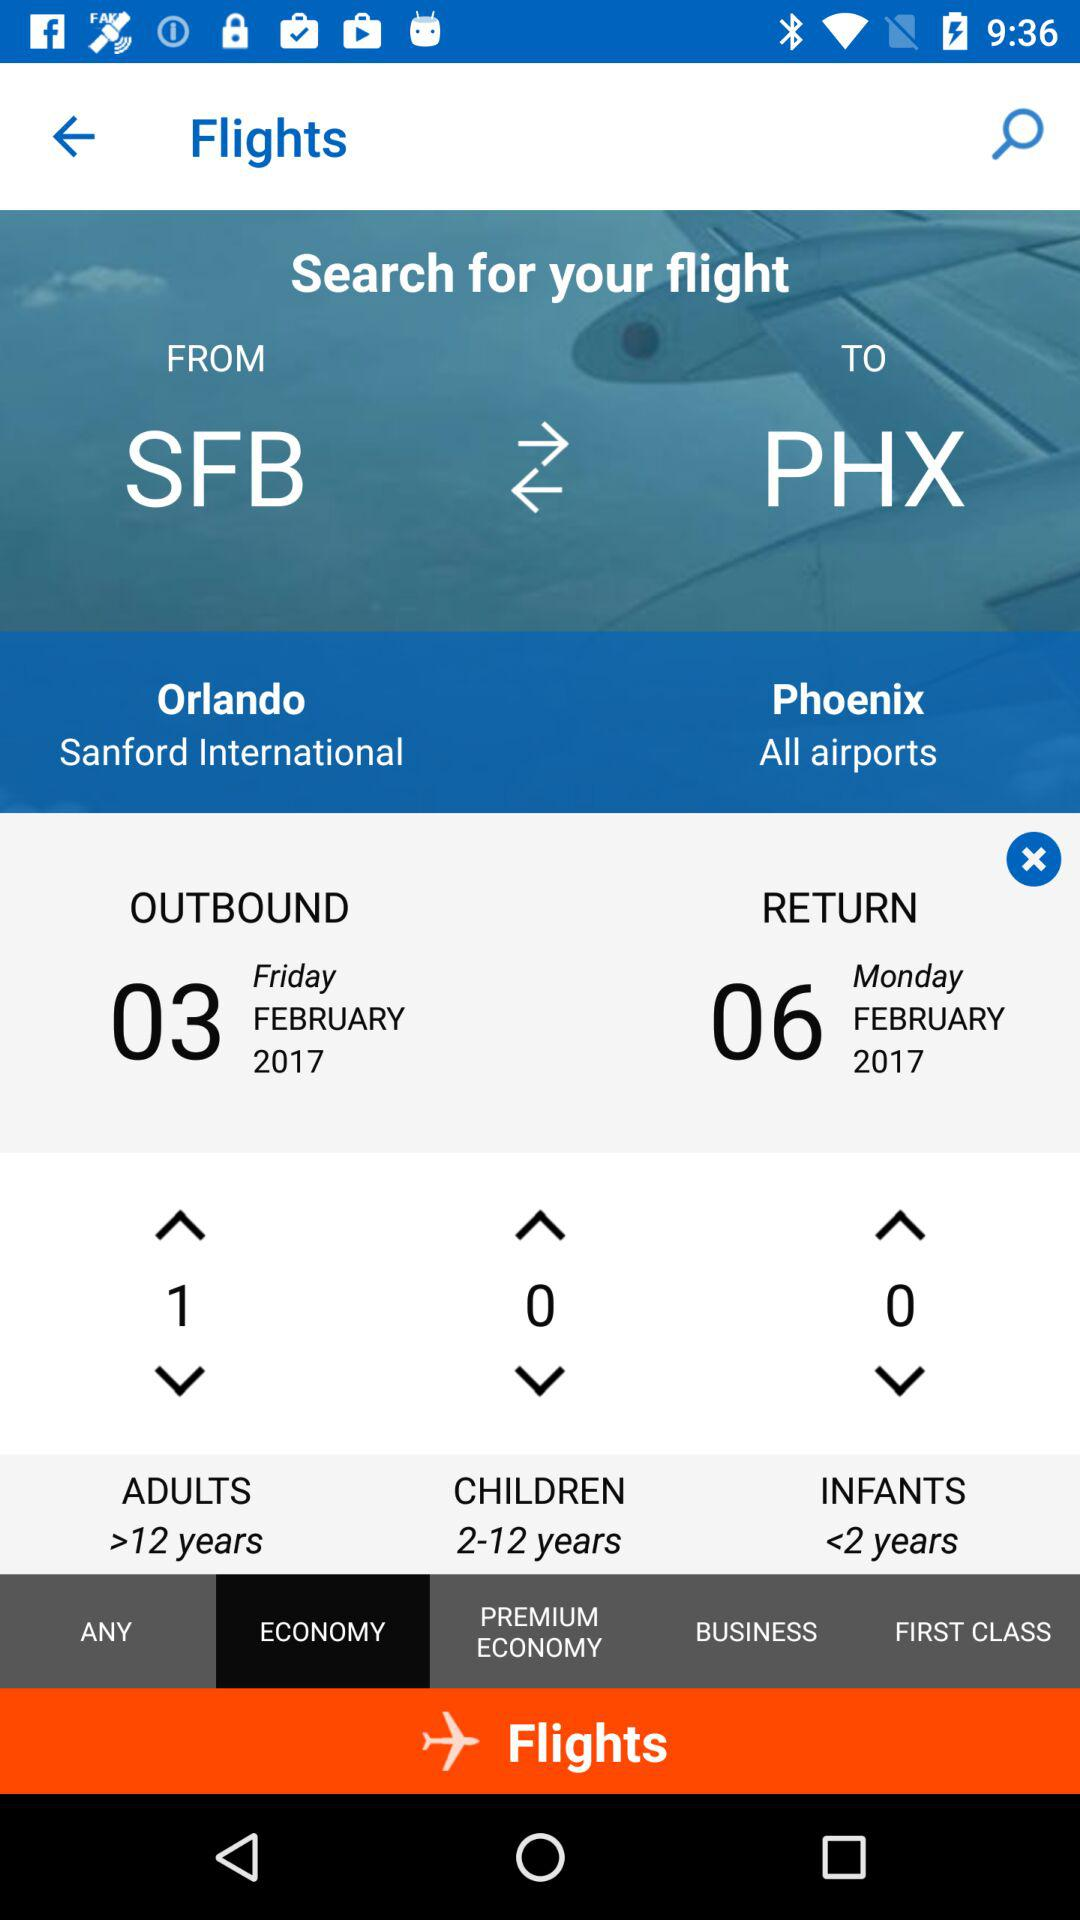How many more adults are there than children?
Answer the question using a single word or phrase. 1 